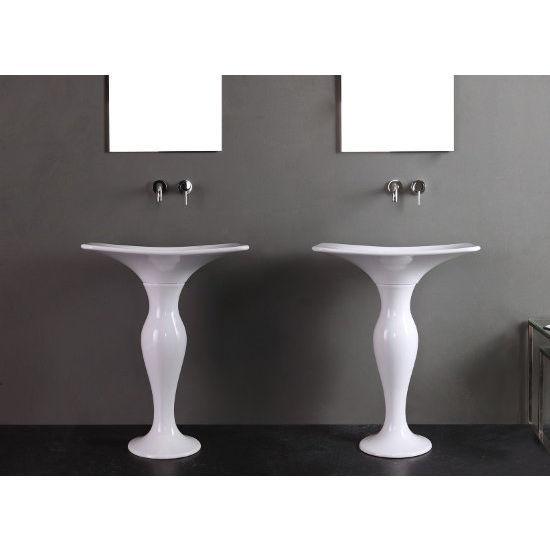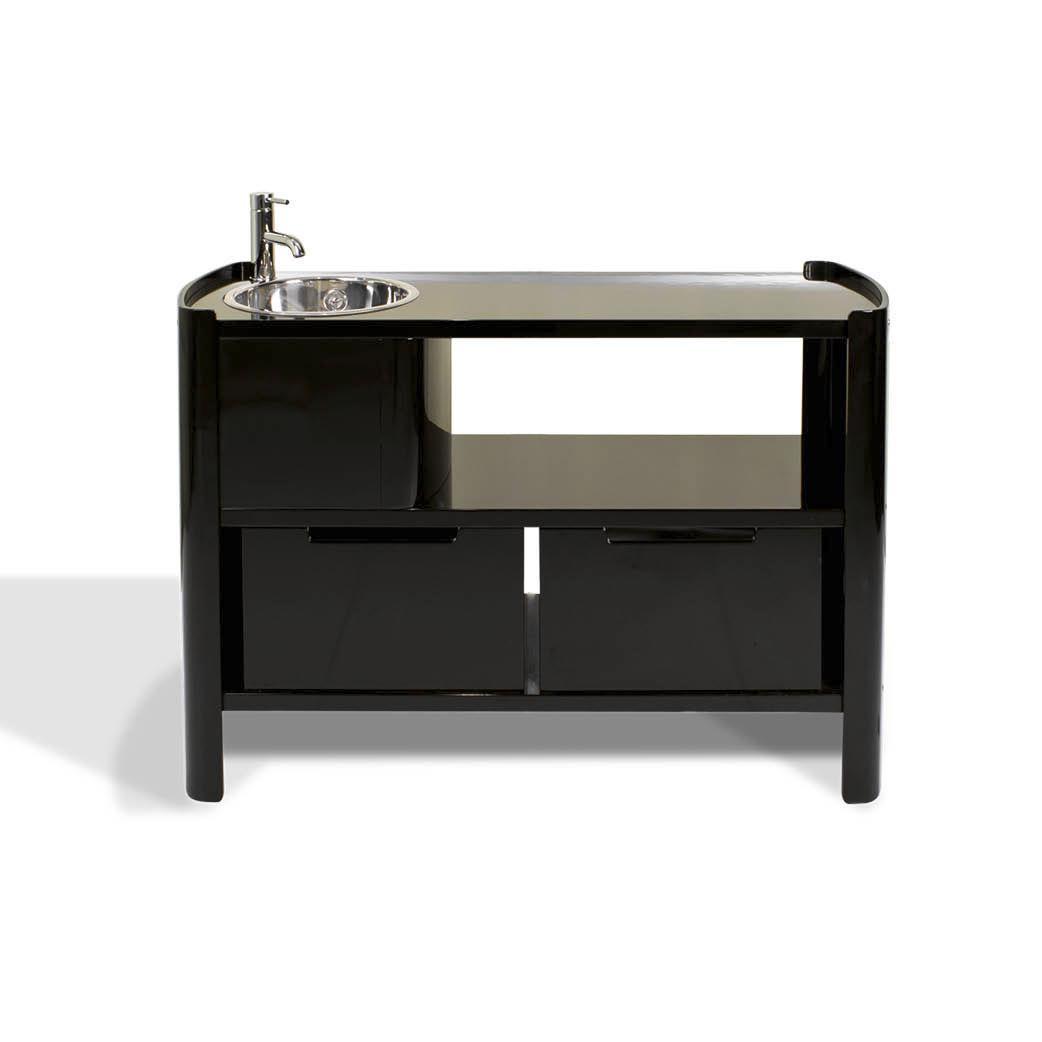The first image is the image on the left, the second image is the image on the right. Considering the images on both sides, is "The right image features a reclined chair positioned under a small sink." valid? Answer yes or no. No. The first image is the image on the left, the second image is the image on the right. For the images displayed, is the sentence "One of the images features two sinks." factually correct? Answer yes or no. Yes. 